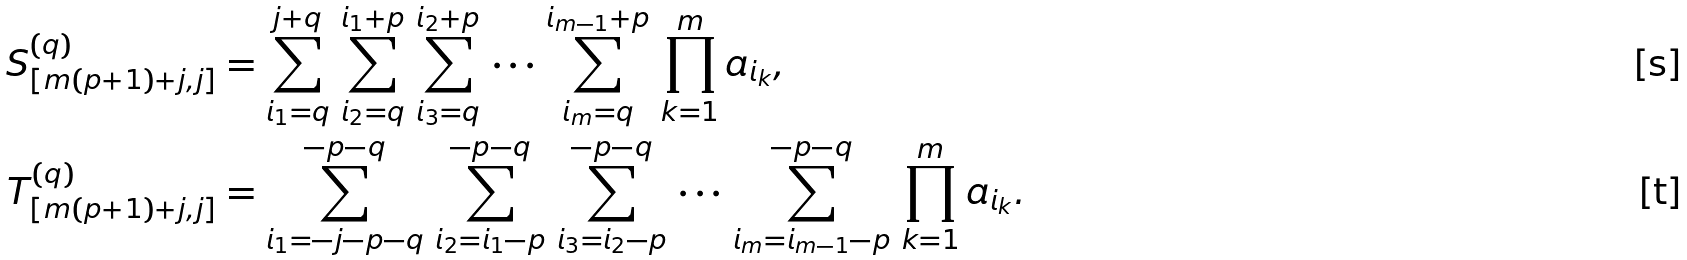Convert formula to latex. <formula><loc_0><loc_0><loc_500><loc_500>S _ { [ m ( p + 1 ) + j , j ] } ^ { ( q ) } & = \sum _ { i _ { 1 } = q } ^ { j + q } \, \sum _ { i _ { 2 } = q } ^ { i _ { 1 } + p } \, \sum _ { i _ { 3 } = q } ^ { i _ { 2 } + p } \, \cdots \, \sum _ { i _ { m } = q } ^ { i _ { m - 1 } + p } \, \prod _ { k = 1 } ^ { m } a _ { i _ { k } } , \\ T _ { [ m ( p + 1 ) + j , j ] } ^ { ( q ) } & = \sum _ { i _ { 1 } = - j - p - q } ^ { - p - q } \, \sum _ { i _ { 2 } = i _ { 1 } - p } ^ { - p - q } \, \sum _ { i _ { 3 } = i _ { 2 } - p } ^ { - p - q } \, \cdots \, \sum _ { i _ { m } = i _ { m - 1 } - p } ^ { - p - q } \, \prod _ { k = 1 } ^ { m } a _ { i _ { k } } .</formula> 